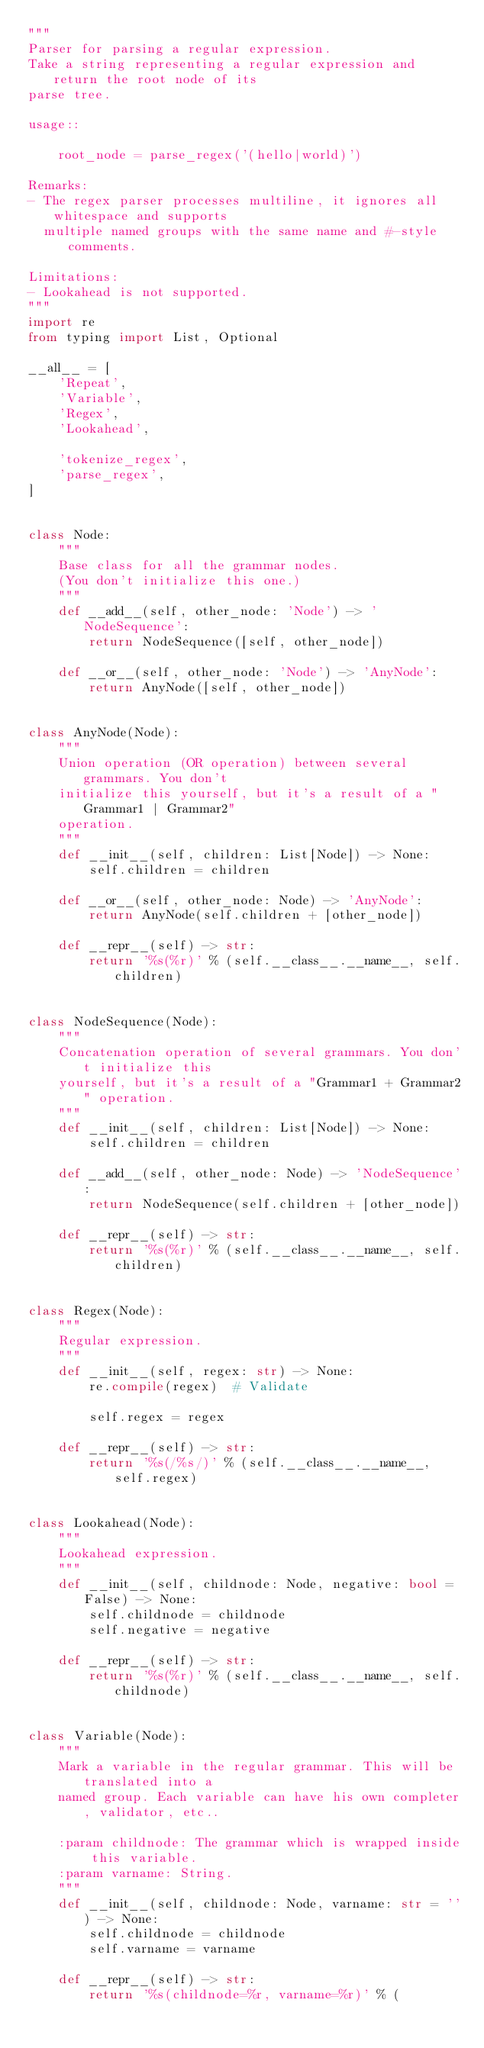Convert code to text. <code><loc_0><loc_0><loc_500><loc_500><_Python_>"""
Parser for parsing a regular expression.
Take a string representing a regular expression and return the root node of its
parse tree.

usage::

    root_node = parse_regex('(hello|world)')

Remarks:
- The regex parser processes multiline, it ignores all whitespace and supports
  multiple named groups with the same name and #-style comments.

Limitations:
- Lookahead is not supported.
"""
import re
from typing import List, Optional

__all__ = [
    'Repeat',
    'Variable',
    'Regex',
    'Lookahead',

    'tokenize_regex',
    'parse_regex',
]


class Node:
    """
    Base class for all the grammar nodes.
    (You don't initialize this one.)
    """
    def __add__(self, other_node: 'Node') -> 'NodeSequence':
        return NodeSequence([self, other_node])

    def __or__(self, other_node: 'Node') -> 'AnyNode':
        return AnyNode([self, other_node])


class AnyNode(Node):
    """
    Union operation (OR operation) between several grammars. You don't
    initialize this yourself, but it's a result of a "Grammar1 | Grammar2"
    operation.
    """
    def __init__(self, children: List[Node]) -> None:
        self.children = children

    def __or__(self, other_node: Node) -> 'AnyNode':
        return AnyNode(self.children + [other_node])

    def __repr__(self) -> str:
        return '%s(%r)' % (self.__class__.__name__, self.children)


class NodeSequence(Node):
    """
    Concatenation operation of several grammars. You don't initialize this
    yourself, but it's a result of a "Grammar1 + Grammar2" operation.
    """
    def __init__(self, children: List[Node]) -> None:
        self.children = children

    def __add__(self, other_node: Node) -> 'NodeSequence':
        return NodeSequence(self.children + [other_node])

    def __repr__(self) -> str:
        return '%s(%r)' % (self.__class__.__name__, self.children)


class Regex(Node):
    """
    Regular expression.
    """
    def __init__(self, regex: str) -> None:
        re.compile(regex)  # Validate

        self.regex = regex

    def __repr__(self) -> str:
        return '%s(/%s/)' % (self.__class__.__name__, self.regex)


class Lookahead(Node):
    """
    Lookahead expression.
    """
    def __init__(self, childnode: Node, negative: bool = False) -> None:
        self.childnode = childnode
        self.negative = negative

    def __repr__(self) -> str:
        return '%s(%r)' % (self.__class__.__name__, self.childnode)


class Variable(Node):
    """
    Mark a variable in the regular grammar. This will be translated into a
    named group. Each variable can have his own completer, validator, etc..

    :param childnode: The grammar which is wrapped inside this variable.
    :param varname: String.
    """
    def __init__(self, childnode: Node, varname: str = '') -> None:
        self.childnode = childnode
        self.varname = varname

    def __repr__(self) -> str:
        return '%s(childnode=%r, varname=%r)' % (</code> 